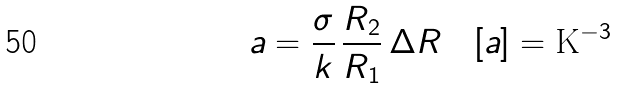<formula> <loc_0><loc_0><loc_500><loc_500>a = \frac { \sigma } { k } \, \frac { R _ { 2 } } { R _ { 1 } } \, \Delta R \quad [ a ] = \text {K} ^ { - 3 }</formula> 